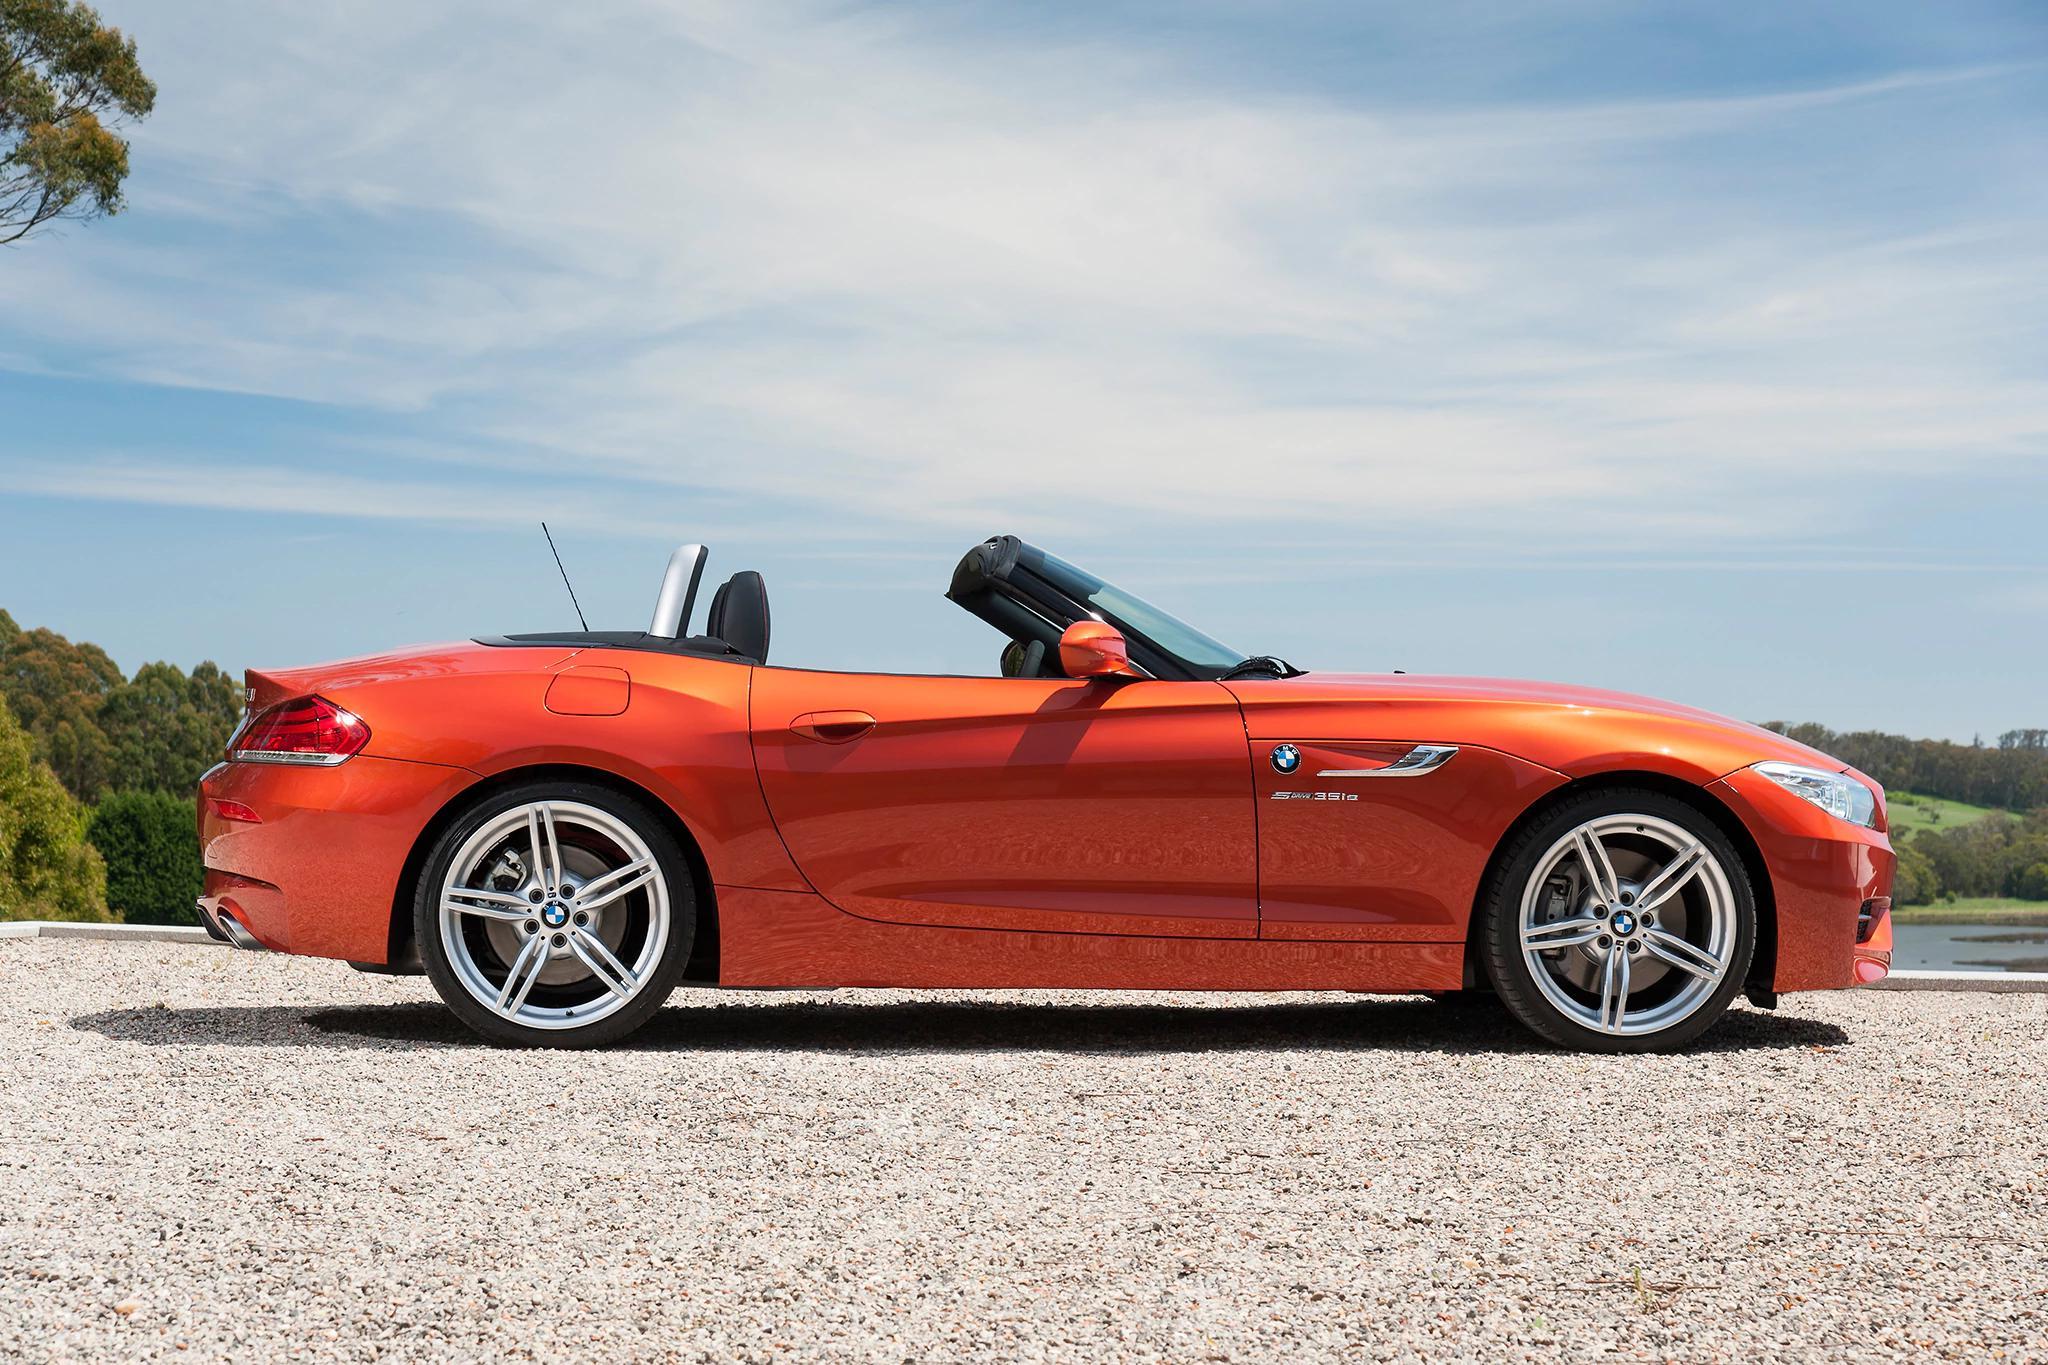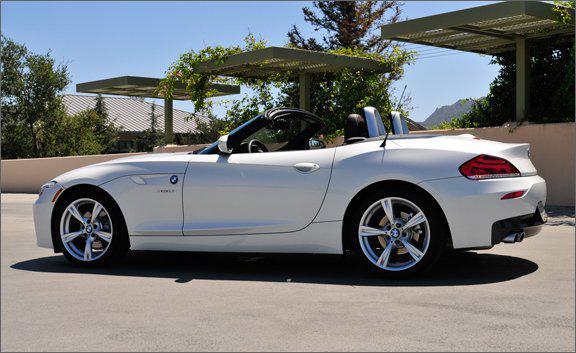The first image is the image on the left, the second image is the image on the right. Considering the images on both sides, is "One image has an orange BMW facing the right." valid? Answer yes or no. Yes. The first image is the image on the left, the second image is the image on the right. Considering the images on both sides, is "In at least one image  there is a orange convertible top car with thin tires and silver rims pointed  left." valid? Answer yes or no. Yes. 